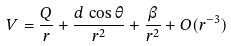<formula> <loc_0><loc_0><loc_500><loc_500>V = \frac { Q } { r } + \frac { d \, \cos \theta } { r ^ { 2 } } + \frac { \beta } { r ^ { 2 } } + O ( r ^ { - 3 } )</formula> 